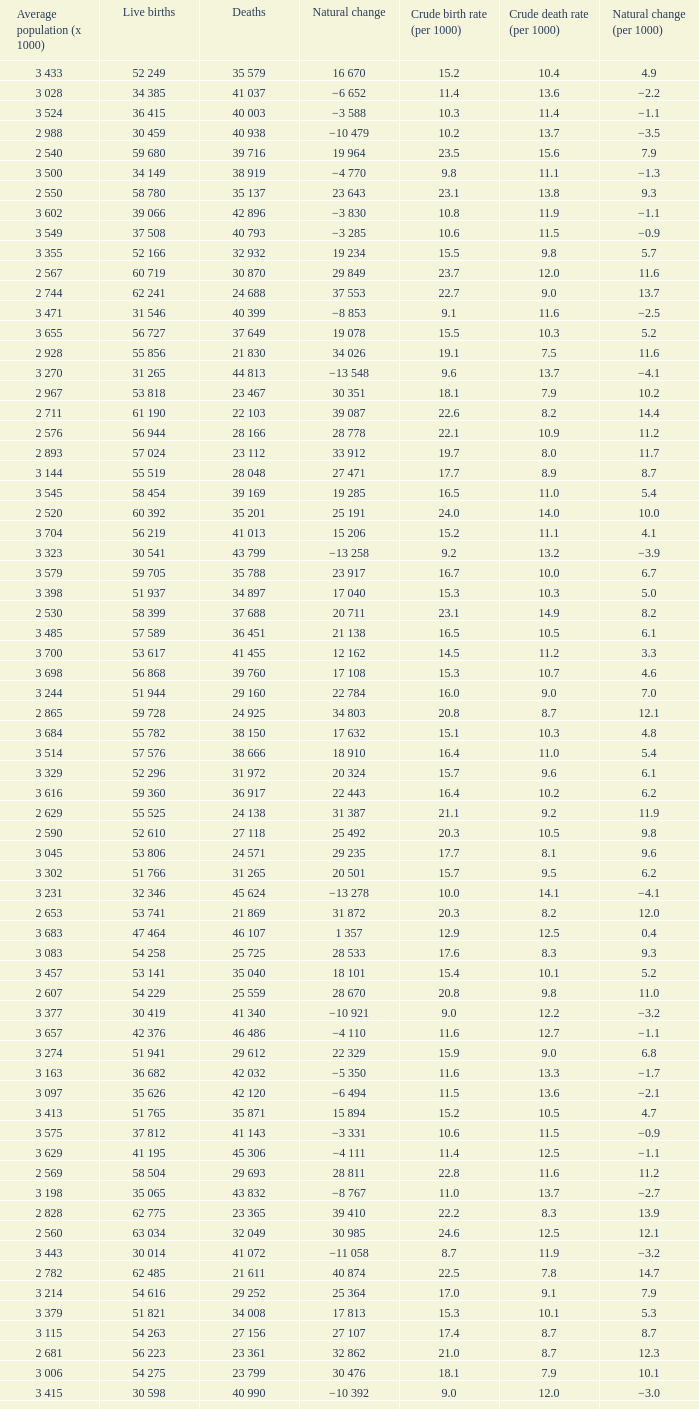Can you give me this table as a dict? {'header': ['Average population (x 1000)', 'Live births', 'Deaths', 'Natural change', 'Crude birth rate (per 1000)', 'Crude death rate (per 1000)', 'Natural change (per 1000)'], 'rows': [['3 433', '52 249', '35 579', '16 670', '15.2', '10.4', '4.9'], ['3 028', '34 385', '41 037', '−6 652', '11.4', '13.6', '−2.2'], ['3 524', '36 415', '40 003', '−3 588', '10.3', '11.4', '−1.1'], ['2 988', '30 459', '40 938', '−10 479', '10.2', '13.7', '−3.5'], ['2 540', '59 680', '39 716', '19 964', '23.5', '15.6', '7.9'], ['3 500', '34 149', '38 919', '−4 770', '9.8', '11.1', '−1.3'], ['2 550', '58 780', '35 137', '23 643', '23.1', '13.8', '9.3'], ['3 602', '39 066', '42 896', '−3 830', '10.8', '11.9', '−1.1'], ['3 549', '37 508', '40 793', '−3 285', '10.6', '11.5', '−0.9'], ['3 355', '52 166', '32 932', '19 234', '15.5', '9.8', '5.7'], ['2 567', '60 719', '30 870', '29 849', '23.7', '12.0', '11.6'], ['2 744', '62 241', '24 688', '37 553', '22.7', '9.0', '13.7'], ['3 471', '31 546', '40 399', '−8 853', '9.1', '11.6', '−2.5'], ['3 655', '56 727', '37 649', '19 078', '15.5', '10.3', '5.2'], ['2 928', '55 856', '21 830', '34 026', '19.1', '7.5', '11.6'], ['3 270', '31 265', '44 813', '−13 548', '9.6', '13.7', '−4.1'], ['2 967', '53 818', '23 467', '30 351', '18.1', '7.9', '10.2'], ['2 711', '61 190', '22 103', '39 087', '22.6', '8.2', '14.4'], ['2 576', '56 944', '28 166', '28 778', '22.1', '10.9', '11.2'], ['2 893', '57 024', '23 112', '33 912', '19.7', '8.0', '11.7'], ['3 144', '55 519', '28 048', '27 471', '17.7', '8.9', '8.7'], ['3 545', '58 454', '39 169', '19 285', '16.5', '11.0', '5.4'], ['2 520', '60 392', '35 201', '25 191', '24.0', '14.0', '10.0'], ['3 704', '56 219', '41 013', '15 206', '15.2', '11.1', '4.1'], ['3 323', '30 541', '43 799', '−13 258', '9.2', '13.2', '−3.9'], ['3 579', '59 705', '35 788', '23 917', '16.7', '10.0', '6.7'], ['3 398', '51 937', '34 897', '17 040', '15.3', '10.3', '5.0'], ['2 530', '58 399', '37 688', '20 711', '23.1', '14.9', '8.2'], ['3 485', '57 589', '36 451', '21 138', '16.5', '10.5', '6.1'], ['3 700', '53 617', '41 455', '12 162', '14.5', '11.2', '3.3'], ['3 698', '56 868', '39 760', '17 108', '15.3', '10.7', '4.6'], ['3 244', '51 944', '29 160', '22 784', '16.0', '9.0', '7.0'], ['2 865', '59 728', '24 925', '34 803', '20.8', '8.7', '12.1'], ['3 684', '55 782', '38 150', '17 632', '15.1', '10.3', '4.8'], ['3 514', '57 576', '38 666', '18 910', '16.4', '11.0', '5.4'], ['3 329', '52 296', '31 972', '20 324', '15.7', '9.6', '6.1'], ['3 616', '59 360', '36 917', '22 443', '16.4', '10.2', '6.2'], ['2 629', '55 525', '24 138', '31 387', '21.1', '9.2', '11.9'], ['2 590', '52 610', '27 118', '25 492', '20.3', '10.5', '9.8'], ['3 045', '53 806', '24 571', '29 235', '17.7', '8.1', '9.6'], ['3 302', '51 766', '31 265', '20 501', '15.7', '9.5', '6.2'], ['3 231', '32 346', '45 624', '−13 278', '10.0', '14.1', '−4.1'], ['2 653', '53 741', '21 869', '31 872', '20.3', '8.2', '12.0'], ['3 683', '47 464', '46 107', '1 357', '12.9', '12.5', '0.4'], ['3 083', '54 258', '25 725', '28 533', '17.6', '8.3', '9.3'], ['3 457', '53 141', '35 040', '18 101', '15.4', '10.1', '5.2'], ['2 607', '54 229', '25 559', '28 670', '20.8', '9.8', '11.0'], ['3 377', '30 419', '41 340', '−10 921', '9.0', '12.2', '−3.2'], ['3 657', '42 376', '46 486', '−4 110', '11.6', '12.7', '−1.1'], ['3 274', '51 941', '29 612', '22 329', '15.9', '9.0', '6.8'], ['3 163', '36 682', '42 032', '−5 350', '11.6', '13.3', '−1.7'], ['3 097', '35 626', '42 120', '−6 494', '11.5', '13.6', '−2.1'], ['3 413', '51 765', '35 871', '15 894', '15.2', '10.5', '4.7'], ['3 575', '37 812', '41 143', '−3 331', '10.6', '11.5', '−0.9'], ['3 629', '41 195', '45 306', '−4 111', '11.4', '12.5', '−1.1'], ['2 569', '58 504', '29 693', '28 811', '22.8', '11.6', '11.2'], ['3 198', '35 065', '43 832', '−8 767', '11.0', '13.7', '−2.7'], ['2 828', '62 775', '23 365', '39 410', '22.2', '8.3', '13.9'], ['2 560', '63 034', '32 049', '30 985', '24.6', '12.5', '12.1'], ['3 443', '30 014', '41 072', '−11 058', '8.7', '11.9', '−3.2'], ['2 782', '62 485', '21 611', '40 874', '22.5', '7.8', '14.7'], ['3 214', '54 616', '29 252', '25 364', '17.0', '9.1', '7.9'], ['3 379', '51 821', '34 008', '17 813', '15.3', '10.1', '5.3'], ['3 115', '54 263', '27 156', '27 107', '17.4', '8.7', '8.7'], ['2 681', '56 223', '23 361', '32 862', '21.0', '8.7', '12.3'], ['3 006', '54 275', '23 799', '30 476', '18.1', '7.9', '10.1'], ['3 415', '30 598', '40 990', '−10 392', '9.0', '12.0', '−3.0'], ['3 179', '56 044', '26 972', '29 072', '17.6', '8.5', '9.1']]} Which Average population (x 1000) has a Crude death rate (per 1000) smaller than 10.9, and a Crude birth rate (per 1000) smaller than 19.7, and a Natural change (per 1000) of 8.7, and Live births of 54 263? 3 115. 